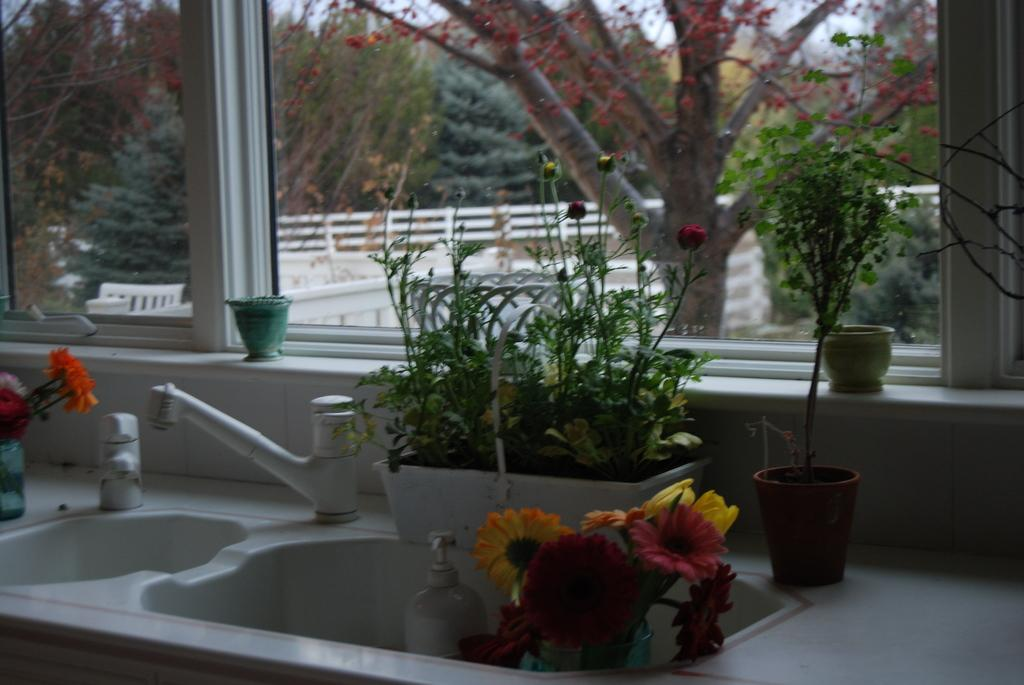What can be found in the image that is used for washing or cleaning? There is a sink in the image that can be used for washing or cleaning. What feature does the sink have? The sink has taps. What type of plants are present in the image? There are potted plants in the image. What is visible through the window in the image? Trees and a railing are visible through the window. Is there any milk visible in the image? No, there is no milk present in the image. Can you see any cobwebs in the image? No, there are no cobwebs visible in the image. 